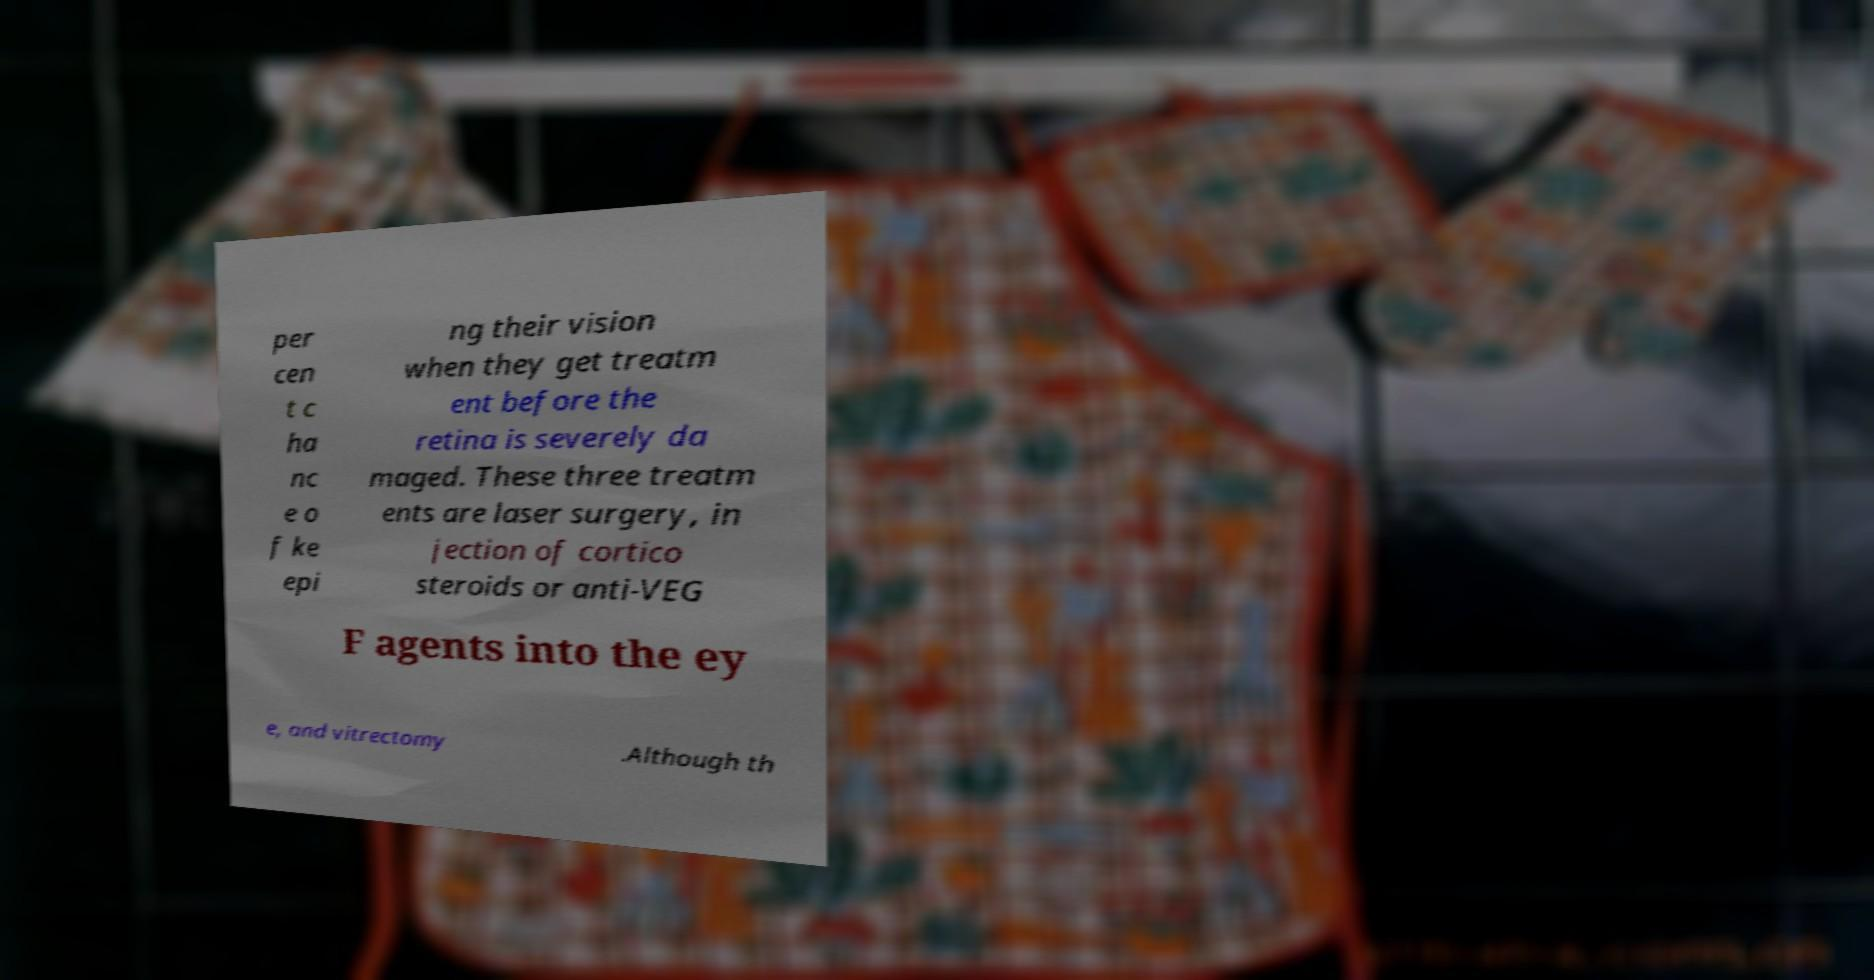Could you extract and type out the text from this image? per cen t c ha nc e o f ke epi ng their vision when they get treatm ent before the retina is severely da maged. These three treatm ents are laser surgery, in jection of cortico steroids or anti-VEG F agents into the ey e, and vitrectomy .Although th 